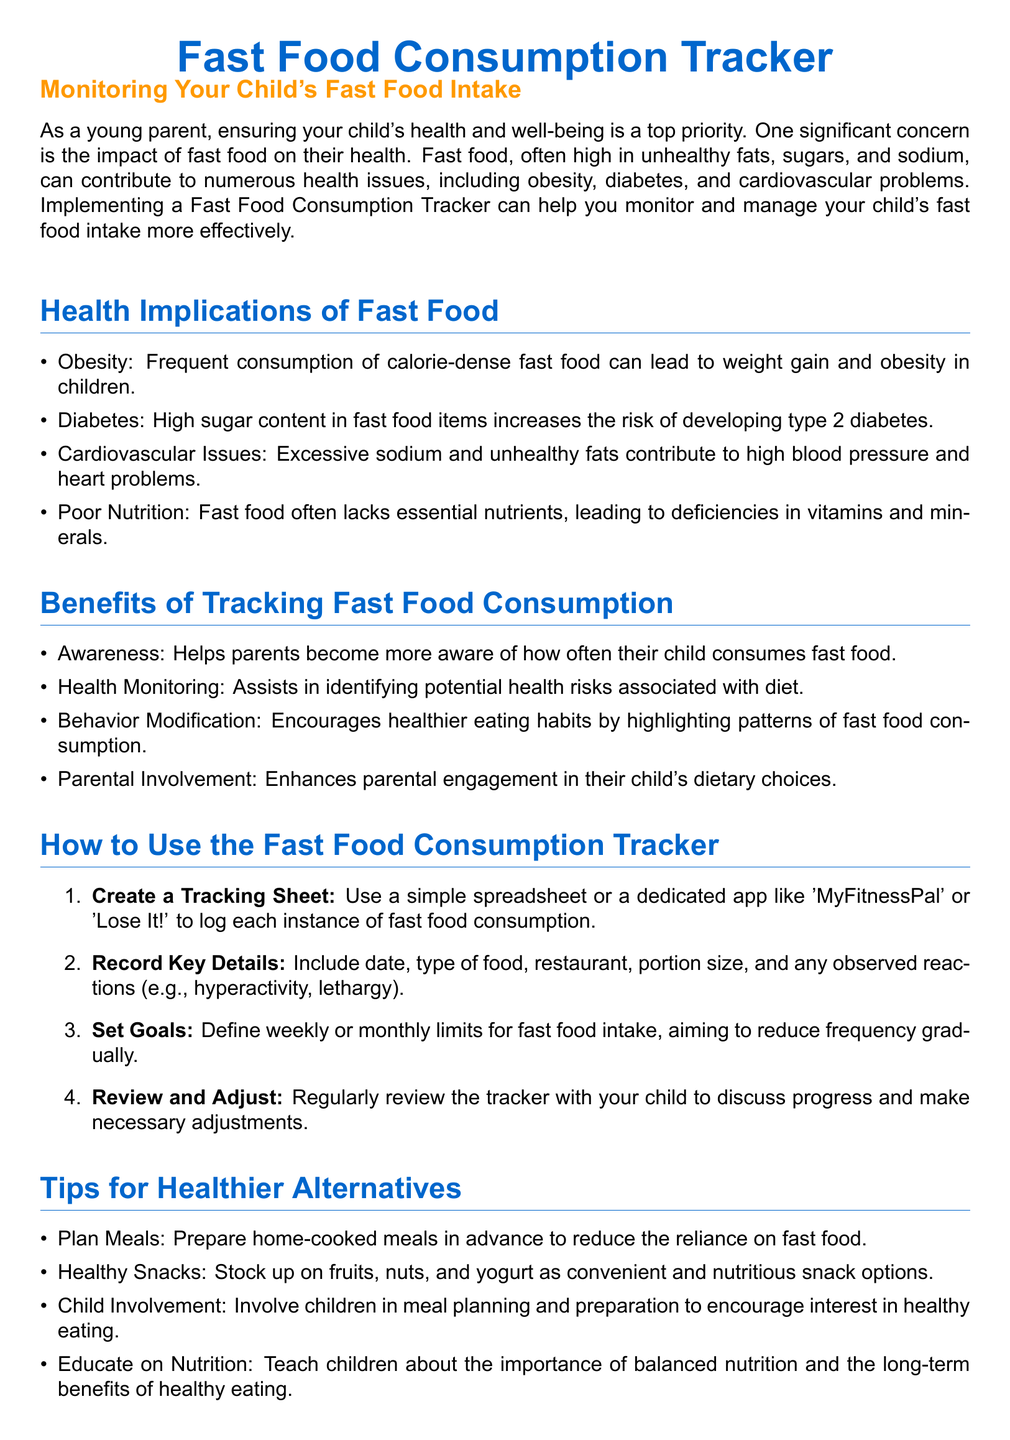what are the health implications of fast food? The document lists several health implications including obesity, diabetes, cardiovascular issues, and poor nutrition.
Answer: obesity, diabetes, cardiovascular issues, poor nutrition what is one benefit of tracking fast food consumption? One of the benefits mentioned is that it helps parents become more aware of how often their child consumes fast food.
Answer: Awareness how many key details should be recorded in the tracker? The document suggests recording key details such as the date, type of food, restaurant, portion size, and any observed reactions.
Answer: Five what is one tip for healthier alternatives? The document provides suggestions like planning meals, healthy snacks, child involvement, and educating on nutrition.
Answer: Plan Meals what should parents set to manage fast food intake? The document recommends defining weekly or monthly limits for fast food intake.
Answer: Goals what can tracking fast food consumption lead to? The text mentions that it encourages healthier eating habits by highlighting patterns of fast food consumption.
Answer: Behavior Modification how can parents enhance their engagement in their child's diet? The document states that tracking fast food consumption enhances parental involvement in their child's dietary choices.
Answer: Parental Involvement what is recommended to do with the tracker regularly? It's recommended to review the tracker with the child to discuss progress and make necessary adjustments.
Answer: Review and Adjust 